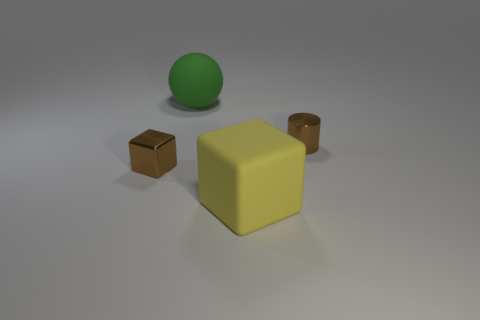Do the small metal cube and the small metal cylinder have the same color?
Make the answer very short. Yes. Are any tiny brown rubber cubes visible?
Your answer should be compact. No. There is a block that is behind the rubber block; what is it made of?
Make the answer very short. Metal. There is a object that is the same color as the small cylinder; what material is it?
Your answer should be very brief. Metal. What number of big things are either spheres or brown rubber spheres?
Provide a short and direct response. 1. What is the color of the small cube?
Your response must be concise. Brown. There is a small metal object that is in front of the tiny brown cylinder; is there a brown metal object to the right of it?
Your answer should be compact. Yes. Is the number of shiny blocks that are on the right side of the green rubber object less than the number of small brown cubes?
Keep it short and to the point. Yes. Is the tiny brown object that is on the left side of the big green thing made of the same material as the big cube?
Your answer should be very brief. No. There is another large thing that is the same material as the green object; what color is it?
Make the answer very short. Yellow. 